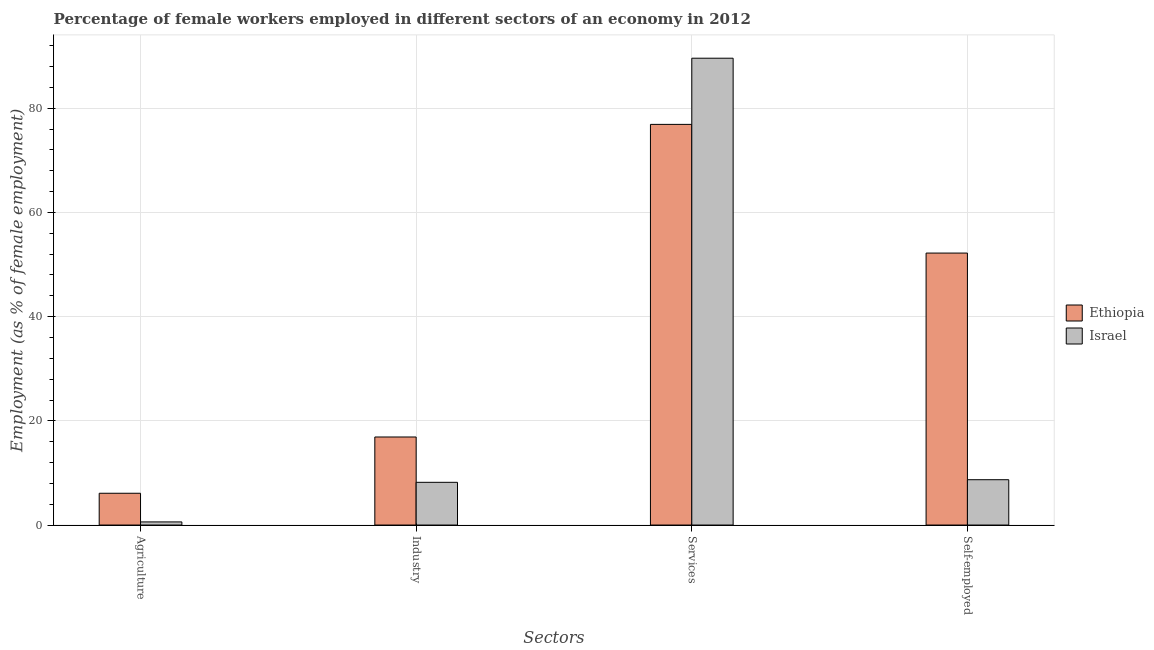How many groups of bars are there?
Make the answer very short. 4. How many bars are there on the 1st tick from the left?
Give a very brief answer. 2. What is the label of the 4th group of bars from the left?
Keep it short and to the point. Self-employed. What is the percentage of female workers in services in Israel?
Ensure brevity in your answer.  89.6. Across all countries, what is the maximum percentage of female workers in agriculture?
Offer a very short reply. 6.1. Across all countries, what is the minimum percentage of self employed female workers?
Offer a very short reply. 8.7. In which country was the percentage of self employed female workers maximum?
Keep it short and to the point. Ethiopia. What is the total percentage of female workers in services in the graph?
Offer a very short reply. 166.5. What is the difference between the percentage of self employed female workers in Ethiopia and that in Israel?
Make the answer very short. 43.5. What is the difference between the percentage of female workers in services in Israel and the percentage of female workers in industry in Ethiopia?
Ensure brevity in your answer.  72.7. What is the average percentage of female workers in services per country?
Your answer should be very brief. 83.25. What is the difference between the percentage of female workers in industry and percentage of female workers in services in Israel?
Offer a terse response. -81.4. What is the ratio of the percentage of female workers in services in Ethiopia to that in Israel?
Your response must be concise. 0.86. Is the difference between the percentage of female workers in industry in Ethiopia and Israel greater than the difference between the percentage of female workers in agriculture in Ethiopia and Israel?
Provide a short and direct response. Yes. What is the difference between the highest and the second highest percentage of female workers in agriculture?
Ensure brevity in your answer.  5.5. What is the difference between the highest and the lowest percentage of self employed female workers?
Offer a very short reply. 43.5. Is the sum of the percentage of female workers in industry in Israel and Ethiopia greater than the maximum percentage of self employed female workers across all countries?
Make the answer very short. No. Is it the case that in every country, the sum of the percentage of self employed female workers and percentage of female workers in industry is greater than the sum of percentage of female workers in agriculture and percentage of female workers in services?
Provide a succinct answer. Yes. What does the 1st bar from the left in Agriculture represents?
Your answer should be very brief. Ethiopia. What does the 2nd bar from the right in Industry represents?
Offer a very short reply. Ethiopia. How many bars are there?
Offer a terse response. 8. Are all the bars in the graph horizontal?
Give a very brief answer. No. How many countries are there in the graph?
Provide a short and direct response. 2. What is the difference between two consecutive major ticks on the Y-axis?
Ensure brevity in your answer.  20. Does the graph contain grids?
Give a very brief answer. Yes. How are the legend labels stacked?
Your answer should be compact. Vertical. What is the title of the graph?
Keep it short and to the point. Percentage of female workers employed in different sectors of an economy in 2012. Does "Cyprus" appear as one of the legend labels in the graph?
Give a very brief answer. No. What is the label or title of the X-axis?
Give a very brief answer. Sectors. What is the label or title of the Y-axis?
Provide a short and direct response. Employment (as % of female employment). What is the Employment (as % of female employment) of Ethiopia in Agriculture?
Keep it short and to the point. 6.1. What is the Employment (as % of female employment) in Israel in Agriculture?
Your answer should be compact. 0.6. What is the Employment (as % of female employment) in Ethiopia in Industry?
Your answer should be very brief. 16.9. What is the Employment (as % of female employment) in Israel in Industry?
Keep it short and to the point. 8.2. What is the Employment (as % of female employment) in Ethiopia in Services?
Offer a very short reply. 76.9. What is the Employment (as % of female employment) in Israel in Services?
Make the answer very short. 89.6. What is the Employment (as % of female employment) of Ethiopia in Self-employed?
Give a very brief answer. 52.2. What is the Employment (as % of female employment) of Israel in Self-employed?
Your answer should be compact. 8.7. Across all Sectors, what is the maximum Employment (as % of female employment) in Ethiopia?
Ensure brevity in your answer.  76.9. Across all Sectors, what is the maximum Employment (as % of female employment) in Israel?
Ensure brevity in your answer.  89.6. Across all Sectors, what is the minimum Employment (as % of female employment) of Ethiopia?
Provide a succinct answer. 6.1. Across all Sectors, what is the minimum Employment (as % of female employment) of Israel?
Provide a succinct answer. 0.6. What is the total Employment (as % of female employment) in Ethiopia in the graph?
Ensure brevity in your answer.  152.1. What is the total Employment (as % of female employment) of Israel in the graph?
Make the answer very short. 107.1. What is the difference between the Employment (as % of female employment) of Ethiopia in Agriculture and that in Industry?
Provide a succinct answer. -10.8. What is the difference between the Employment (as % of female employment) in Ethiopia in Agriculture and that in Services?
Make the answer very short. -70.8. What is the difference between the Employment (as % of female employment) in Israel in Agriculture and that in Services?
Your answer should be compact. -89. What is the difference between the Employment (as % of female employment) in Ethiopia in Agriculture and that in Self-employed?
Ensure brevity in your answer.  -46.1. What is the difference between the Employment (as % of female employment) of Ethiopia in Industry and that in Services?
Your answer should be very brief. -60. What is the difference between the Employment (as % of female employment) in Israel in Industry and that in Services?
Offer a very short reply. -81.4. What is the difference between the Employment (as % of female employment) of Ethiopia in Industry and that in Self-employed?
Give a very brief answer. -35.3. What is the difference between the Employment (as % of female employment) of Ethiopia in Services and that in Self-employed?
Provide a succinct answer. 24.7. What is the difference between the Employment (as % of female employment) of Israel in Services and that in Self-employed?
Offer a terse response. 80.9. What is the difference between the Employment (as % of female employment) of Ethiopia in Agriculture and the Employment (as % of female employment) of Israel in Services?
Keep it short and to the point. -83.5. What is the difference between the Employment (as % of female employment) in Ethiopia in Agriculture and the Employment (as % of female employment) in Israel in Self-employed?
Keep it short and to the point. -2.6. What is the difference between the Employment (as % of female employment) in Ethiopia in Industry and the Employment (as % of female employment) in Israel in Services?
Ensure brevity in your answer.  -72.7. What is the difference between the Employment (as % of female employment) in Ethiopia in Industry and the Employment (as % of female employment) in Israel in Self-employed?
Offer a terse response. 8.2. What is the difference between the Employment (as % of female employment) in Ethiopia in Services and the Employment (as % of female employment) in Israel in Self-employed?
Your response must be concise. 68.2. What is the average Employment (as % of female employment) in Ethiopia per Sectors?
Offer a very short reply. 38.02. What is the average Employment (as % of female employment) in Israel per Sectors?
Your answer should be compact. 26.77. What is the difference between the Employment (as % of female employment) in Ethiopia and Employment (as % of female employment) in Israel in Agriculture?
Provide a succinct answer. 5.5. What is the difference between the Employment (as % of female employment) of Ethiopia and Employment (as % of female employment) of Israel in Services?
Give a very brief answer. -12.7. What is the difference between the Employment (as % of female employment) of Ethiopia and Employment (as % of female employment) of Israel in Self-employed?
Ensure brevity in your answer.  43.5. What is the ratio of the Employment (as % of female employment) of Ethiopia in Agriculture to that in Industry?
Your answer should be very brief. 0.36. What is the ratio of the Employment (as % of female employment) in Israel in Agriculture to that in Industry?
Your response must be concise. 0.07. What is the ratio of the Employment (as % of female employment) in Ethiopia in Agriculture to that in Services?
Give a very brief answer. 0.08. What is the ratio of the Employment (as % of female employment) of Israel in Agriculture to that in Services?
Provide a succinct answer. 0.01. What is the ratio of the Employment (as % of female employment) in Ethiopia in Agriculture to that in Self-employed?
Ensure brevity in your answer.  0.12. What is the ratio of the Employment (as % of female employment) of Israel in Agriculture to that in Self-employed?
Your answer should be compact. 0.07. What is the ratio of the Employment (as % of female employment) in Ethiopia in Industry to that in Services?
Ensure brevity in your answer.  0.22. What is the ratio of the Employment (as % of female employment) in Israel in Industry to that in Services?
Your answer should be very brief. 0.09. What is the ratio of the Employment (as % of female employment) in Ethiopia in Industry to that in Self-employed?
Ensure brevity in your answer.  0.32. What is the ratio of the Employment (as % of female employment) in Israel in Industry to that in Self-employed?
Your response must be concise. 0.94. What is the ratio of the Employment (as % of female employment) of Ethiopia in Services to that in Self-employed?
Provide a short and direct response. 1.47. What is the ratio of the Employment (as % of female employment) in Israel in Services to that in Self-employed?
Provide a succinct answer. 10.3. What is the difference between the highest and the second highest Employment (as % of female employment) of Ethiopia?
Offer a very short reply. 24.7. What is the difference between the highest and the second highest Employment (as % of female employment) in Israel?
Provide a short and direct response. 80.9. What is the difference between the highest and the lowest Employment (as % of female employment) in Ethiopia?
Offer a very short reply. 70.8. What is the difference between the highest and the lowest Employment (as % of female employment) of Israel?
Provide a short and direct response. 89. 